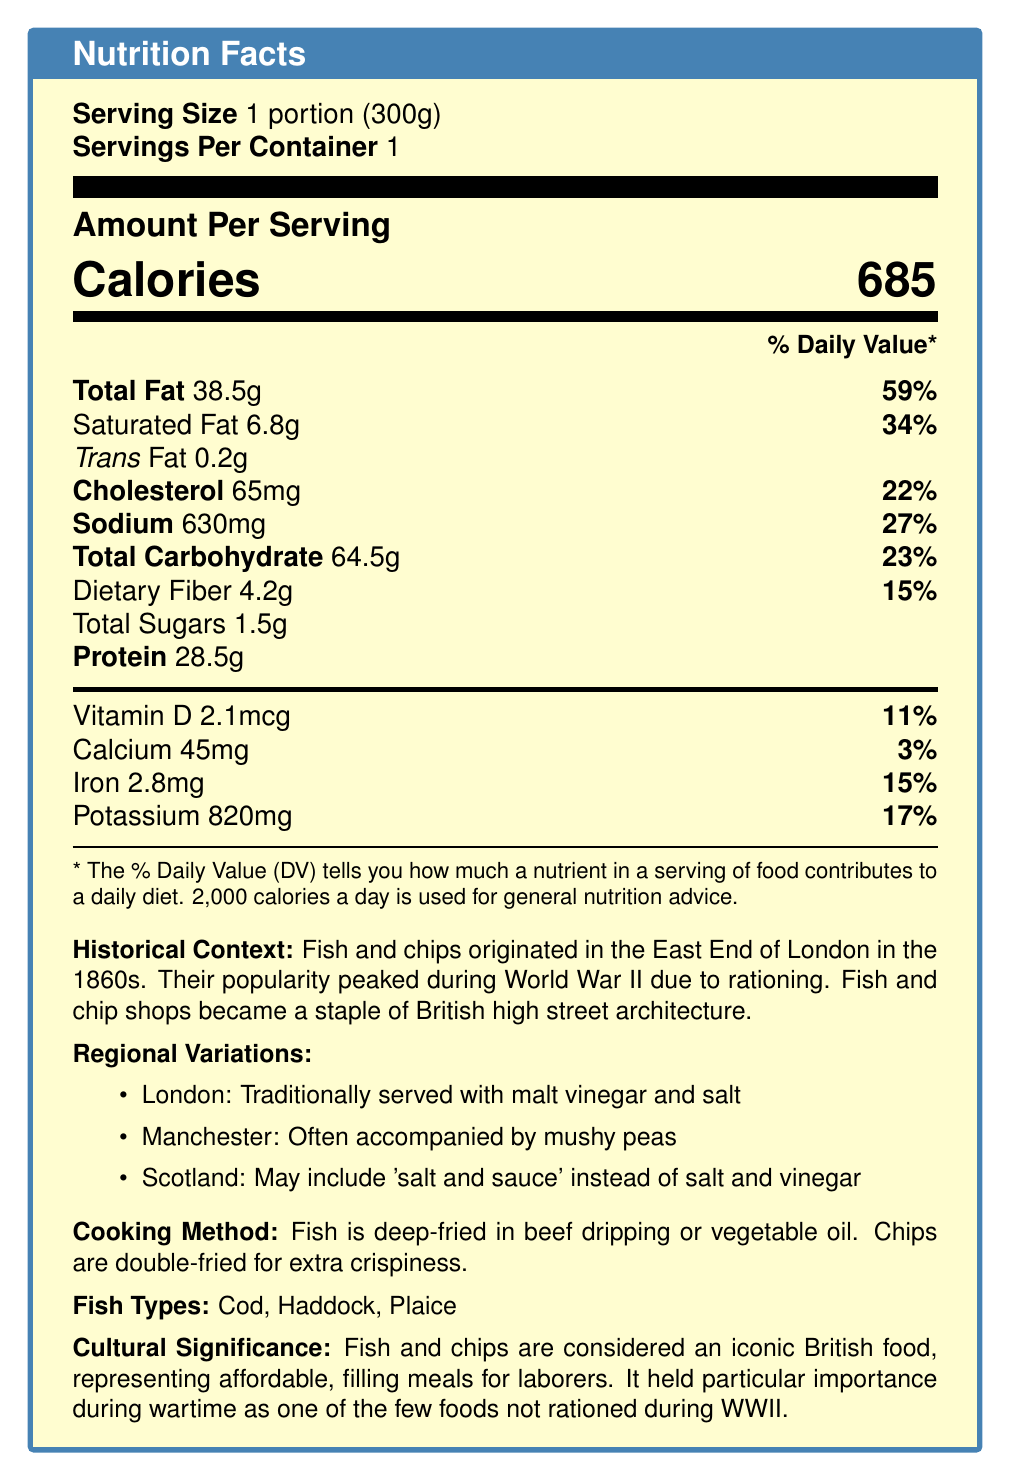How many calories are in one serving of fish and chips? The document specifies that one serving of fish and chips contains 685 calories.
Answer: 685 What is the total fat content in one portion of fish and chips? The document lists the total fat content for one portion as 38.5 grams.
Answer: 38.5g How much of the daily value for saturated fat does one serving provide? According to the document, one serving of fish and chips provides 34% of the daily value for saturated fat.
Answer: 34% What is the amount of trans fat in a serving? The document indicates that there is 0.2 grams of trans fat in one serving.
Answer: 0.2g How much sodium is in one serving of fish and chips? The document specifies that one serving contains 630 milligrams of sodium.
Answer: 630mg A. Cod B. Haddock C. Plaice D. All of the above The document mentions that the types of fish used can be Cod, Haddock, or Plaice.
Answer: D. All of the above A. During World War I B. During the 1950s C. During World War II D. In the 2000s The document notes that the popularity of fish and chips peaked during World War II due to rationing.
Answer: C. During World War II Is the information about how fish and chips are cooked included in the document? The document explains that the fish is deep-fried in beef dripping or vegetable oil and the chips are double-fried for extra crispiness.
Answer: Yes Summarize the main historical and cultural significance of fish and chips as described in the document. The document provides a brief history, notes on regional variations, the cooking method, and the types of fish used, emphasizing its cultural significance as a staple working-class cuisine and its iconic status.
Answer: Fish and chips originated in the East End of London in the 1860s, became popular during WWII due to rationing, and are considered an iconic British food. They represent affordable, filling meals for laborers and were a staple in British high street architecture. What is the serving size for fish and chips? The document clearly states that one serving size is equivalent to 1 portion, which weighs 300 grams.
Answer: 1 portion (300g) How much dietary fiber is in one serving of fish and chips? The document lists the dietary fiber content as 4.2 grams per serving.
Answer: 4.2g What are fish and chips traditionally served with in London? The document details that in London, fish and chips are traditionally served with malt vinegar and salt.
Answer: Malt vinegar and salt What are the main types of fish commonly used for making fish and chips? The document mentions that the main types of fish used in fish and chips include Cod, Haddock, and Plaice.
Answer: Cod, Haddock, Plaice What percentage of the daily value for calcium does one serving of fish and chips provide? The document states that one serving provides 3% of the daily value for calcium.
Answer: 3% What is the total carbohydrate content in a serving? The document specifies that there are 64.5 grams of total carbohydrates in a serving.
Answer: 64.5g Are any details given about how to double-fry the chips? The document mentions that the chips are double-fried for extra crispiness but does not provide specific details on the process.
Answer: Not enough information 